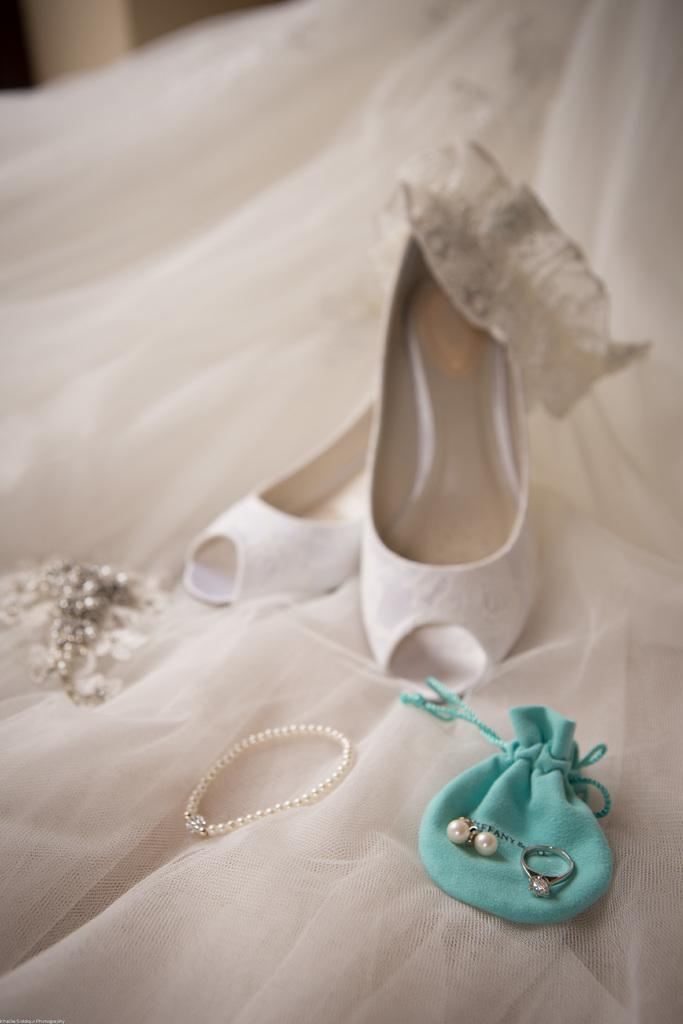What type of jewelry is visible in the image? There is a ring and earrings in the image. How are the ring and earrings stored in the image? The ring and earrings are in a pouch. What other accessories can be seen in the image? There is a hairband, shoes, and a bracelet in the image. Where are the hairband, shoes, and bracelet located in the image? The hairband, shoes, and bracelet are on a white cloth. What type of amusement can be seen in the image? There is no amusement present in the image; it features jewelry and accessories. Can you describe the sea in the image? There is no sea present in the image. 